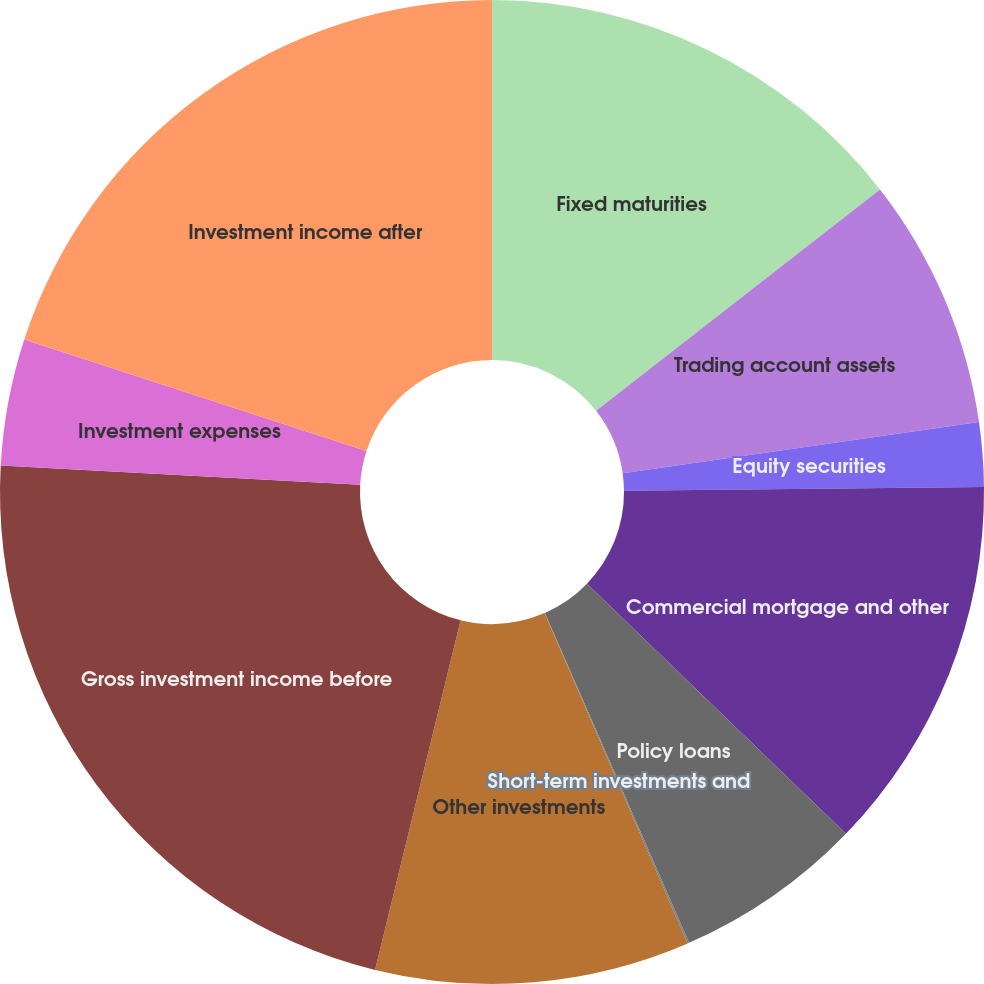<chart> <loc_0><loc_0><loc_500><loc_500><pie_chart><fcel>Fixed maturities<fcel>Trading account assets<fcel>Equity securities<fcel>Commercial mortgage and other<fcel>Policy loans<fcel>Short-term investments and<fcel>Other investments<fcel>Gross investment income before<fcel>Investment expenses<fcel>Investment income after<nl><fcel>14.46%<fcel>8.27%<fcel>2.11%<fcel>12.38%<fcel>6.22%<fcel>0.05%<fcel>10.33%<fcel>22.04%<fcel>4.16%<fcel>19.98%<nl></chart> 